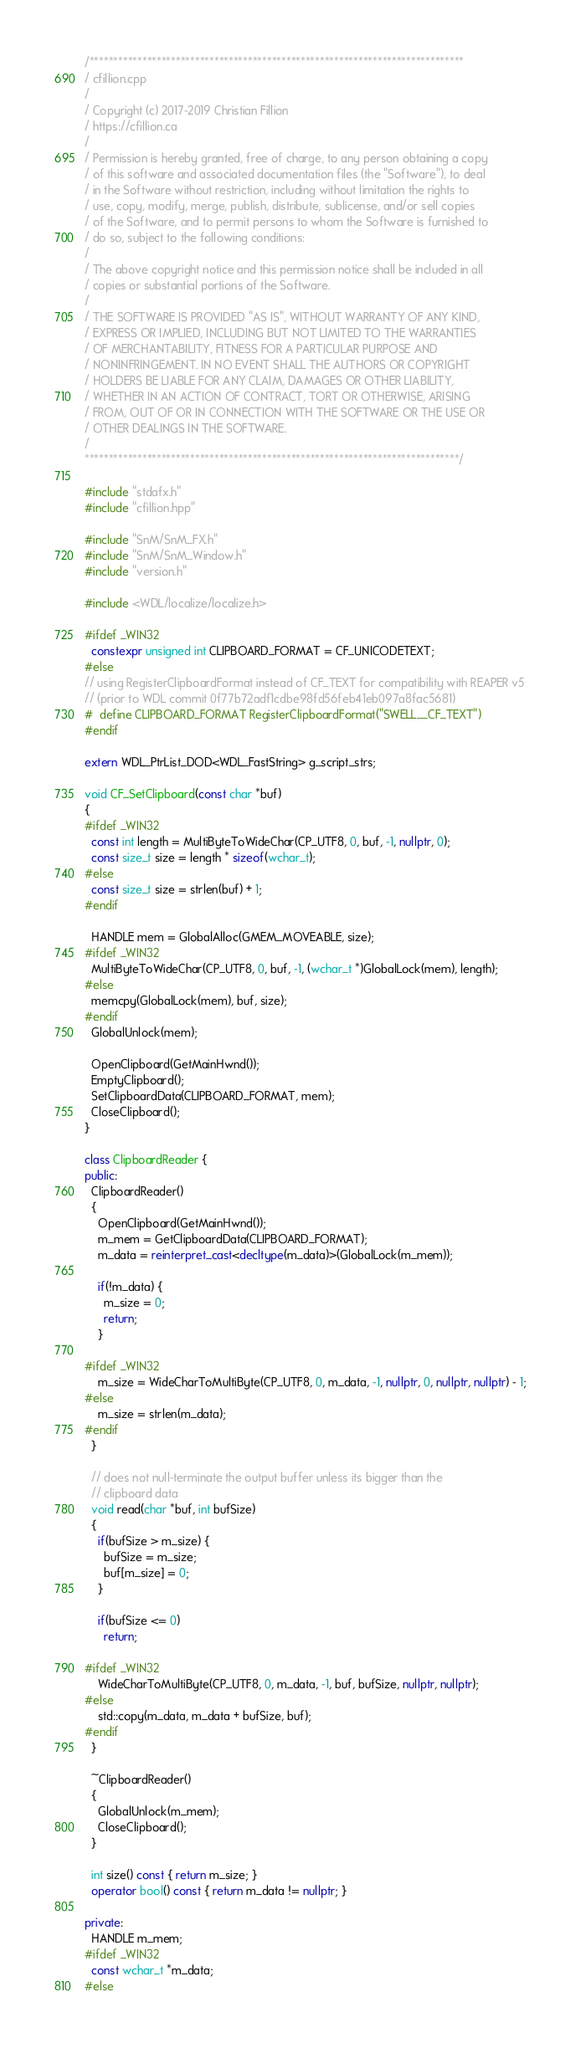<code> <loc_0><loc_0><loc_500><loc_500><_C++_>/******************************************************************************
/ cfillion.cpp
/
/ Copyright (c) 2017-2019 Christian Fillion
/ https://cfillion.ca
/
/ Permission is hereby granted, free of charge, to any person obtaining a copy
/ of this software and associated documentation files (the "Software"), to deal
/ in the Software without restriction, including without limitation the rights to
/ use, copy, modify, merge, publish, distribute, sublicense, and/or sell copies
/ of the Software, and to permit persons to whom the Software is furnished to
/ do so, subject to the following conditions:
/
/ The above copyright notice and this permission notice shall be included in all
/ copies or substantial portions of the Software.
/
/ THE SOFTWARE IS PROVIDED "AS IS", WITHOUT WARRANTY OF ANY KIND,
/ EXPRESS OR IMPLIED, INCLUDING BUT NOT LIMITED TO THE WARRANTIES
/ OF MERCHANTABILITY, FITNESS FOR A PARTICULAR PURPOSE AND
/ NONINFRINGEMENT. IN NO EVENT SHALL THE AUTHORS OR COPYRIGHT
/ HOLDERS BE LIABLE FOR ANY CLAIM, DAMAGES OR OTHER LIABILITY,
/ WHETHER IN AN ACTION OF CONTRACT, TORT OR OTHERWISE, ARISING
/ FROM, OUT OF OR IN CONNECTION WITH THE SOFTWARE OR THE USE OR
/ OTHER DEALINGS IN THE SOFTWARE.
/
******************************************************************************/

#include "stdafx.h"
#include "cfillion.hpp"

#include "SnM/SnM_FX.h"
#include "SnM/SnM_Window.h"
#include "version.h"

#include <WDL/localize/localize.h>

#ifdef _WIN32
  constexpr unsigned int CLIPBOARD_FORMAT = CF_UNICODETEXT;
#else
// using RegisterClipboardFormat instead of CF_TEXT for compatibility with REAPER v5
// (prior to WDL commit 0f77b72adf1cdbe98fd56feb41eb097a8fac5681)
#  define CLIPBOARD_FORMAT RegisterClipboardFormat("SWELL__CF_TEXT")
#endif

extern WDL_PtrList_DOD<WDL_FastString> g_script_strs;

void CF_SetClipboard(const char *buf)
{
#ifdef _WIN32
  const int length = MultiByteToWideChar(CP_UTF8, 0, buf, -1, nullptr, 0);
  const size_t size = length * sizeof(wchar_t);
#else
  const size_t size = strlen(buf) + 1;
#endif

  HANDLE mem = GlobalAlloc(GMEM_MOVEABLE, size);
#ifdef _WIN32
  MultiByteToWideChar(CP_UTF8, 0, buf, -1, (wchar_t *)GlobalLock(mem), length);
#else
  memcpy(GlobalLock(mem), buf, size);
#endif
  GlobalUnlock(mem);

  OpenClipboard(GetMainHwnd());
  EmptyClipboard();
  SetClipboardData(CLIPBOARD_FORMAT, mem);
  CloseClipboard();
}

class ClipboardReader {
public:
  ClipboardReader()
  {
    OpenClipboard(GetMainHwnd());
    m_mem = GetClipboardData(CLIPBOARD_FORMAT);
    m_data = reinterpret_cast<decltype(m_data)>(GlobalLock(m_mem));

    if(!m_data) {
      m_size = 0;
      return;
    }

#ifdef _WIN32
    m_size = WideCharToMultiByte(CP_UTF8, 0, m_data, -1, nullptr, 0, nullptr, nullptr) - 1;
#else
    m_size = strlen(m_data);
#endif
  }

  // does not null-terminate the output buffer unless its bigger than the
  // clipboard data
  void read(char *buf, int bufSize)
  {
    if(bufSize > m_size) {
      bufSize = m_size;
      buf[m_size] = 0;
    }

    if(bufSize <= 0)
      return;

#ifdef _WIN32
    WideCharToMultiByte(CP_UTF8, 0, m_data, -1, buf, bufSize, nullptr, nullptr);
#else
    std::copy(m_data, m_data + bufSize, buf);
#endif
  }

  ~ClipboardReader()
  {
    GlobalUnlock(m_mem);
    CloseClipboard();
  }

  int size() const { return m_size; }
  operator bool() const { return m_data != nullptr; }

private:
  HANDLE m_mem;
#ifdef _WIN32
  const wchar_t *m_data;
#else</code> 